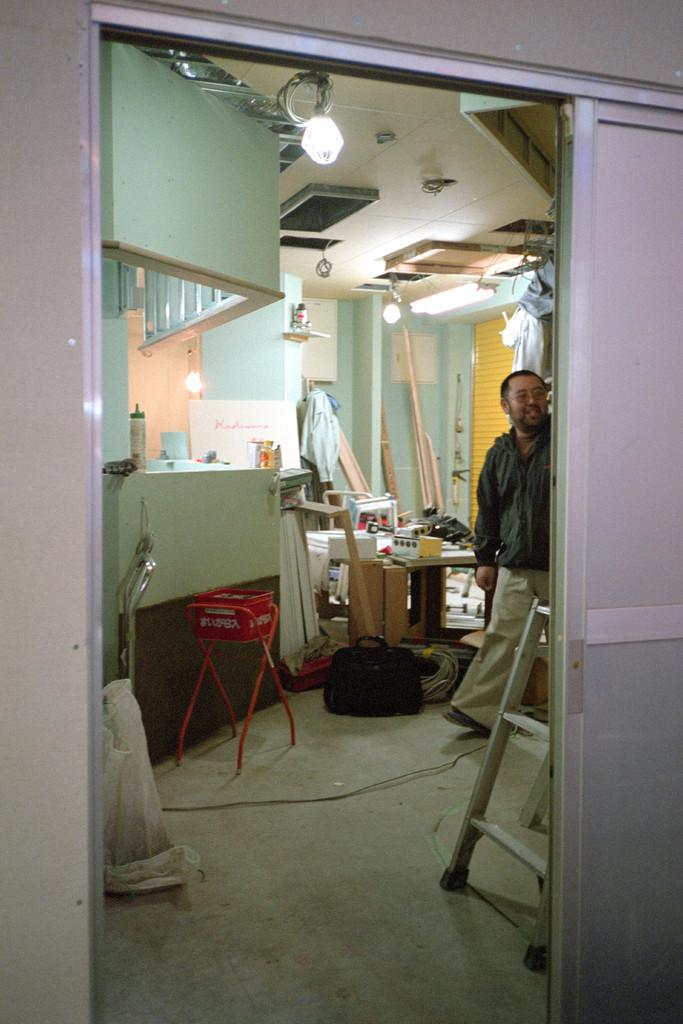What is the person in the image doing? There is a person walking in the image. What object can be seen in the image that is typically used for reaching higher places? There is a ladder in the image. What is on the stand in the image? There is a box on the stand in the image. What can be seen in the background of the image? There are many items visible in the background of the image. What type of lighting is present in the image? There are lights on the ceiling in the image. What type of underwear is the stranger wearing in the image? There is no stranger present in the image, and therefore no information about their underwear can be provided. 